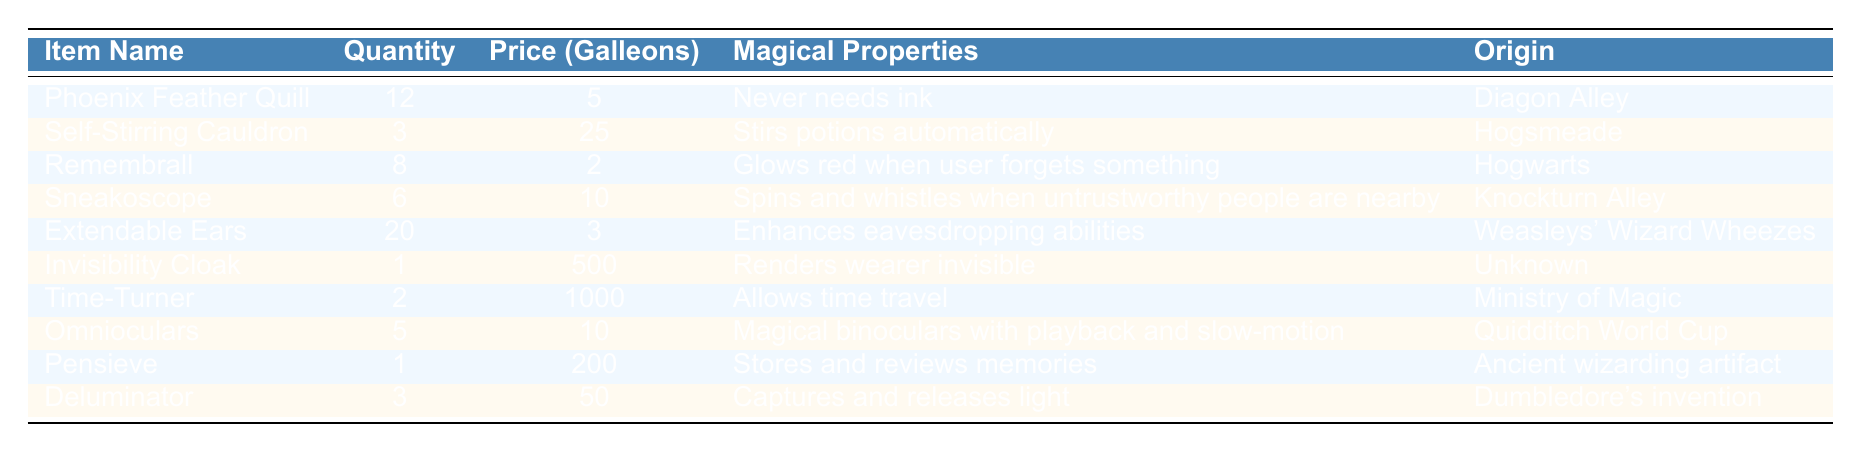What is the price of the Invisibility Cloak? The Invisibility Cloak is listed in the table along with its price. It shows a price of 500 Galleons.
Answer: 500 Galleons How many Self-Stirring Cauldrons are available? The table indicates that there are 3 Self-Stirring Cauldrons in stock.
Answer: 3 What are the magical properties of the Remembrall? By looking at the row for the Remembrall, it is noted that it glows red when the user forgets something.
Answer: Glows red when user forgets something Which item has the highest price? The items need to be compared for their prices, and the Time-Turner is the most expensive at 1000 Galleons.
Answer: Time-Turner What is the total quantity of Extendable Ears and Phoenix Feather Quills combined? Adding the quantities for Extendable Ears (20) and Phoenix Feather Quills (12) gives a total of 32.
Answer: 32 True or False: The Pensieve is an item used to store and review memories. The table states that the Pensieve is used to store and review memories, making this statement true.
Answer: True Which items have a price of 10 Galleons or less? By checking the price column, the following items are found: Remembrall (2 Galleons), Sneakoscope (10 Galleons), and Extendable Ears (3 Galleons).
Answer: Remembrall, Sneakoscope, Extendable Ears What is the average price of all the items listed in the table? The prices of all items are summed up (5 + 25 + 2 + 10 + 3 + 500 + 1000 + 10 + 200 + 50 = 1795). There are 10 items, so the average price is 1795 / 10 = 179.5 Galleons.
Answer: 179.5 Galleons How many items are of unknown origin? Looking at the table, only the Invisibility Cloak has an origin listed as unknown.
Answer: 1 Which item from Hogsmeade is available, and what are its magical properties? Referring to the table, the Self-Stirring Cauldron is from Hogsmeade, and it stirs potions automatically.
Answer: Self-Stirring Cauldron, stirs potions automatically 